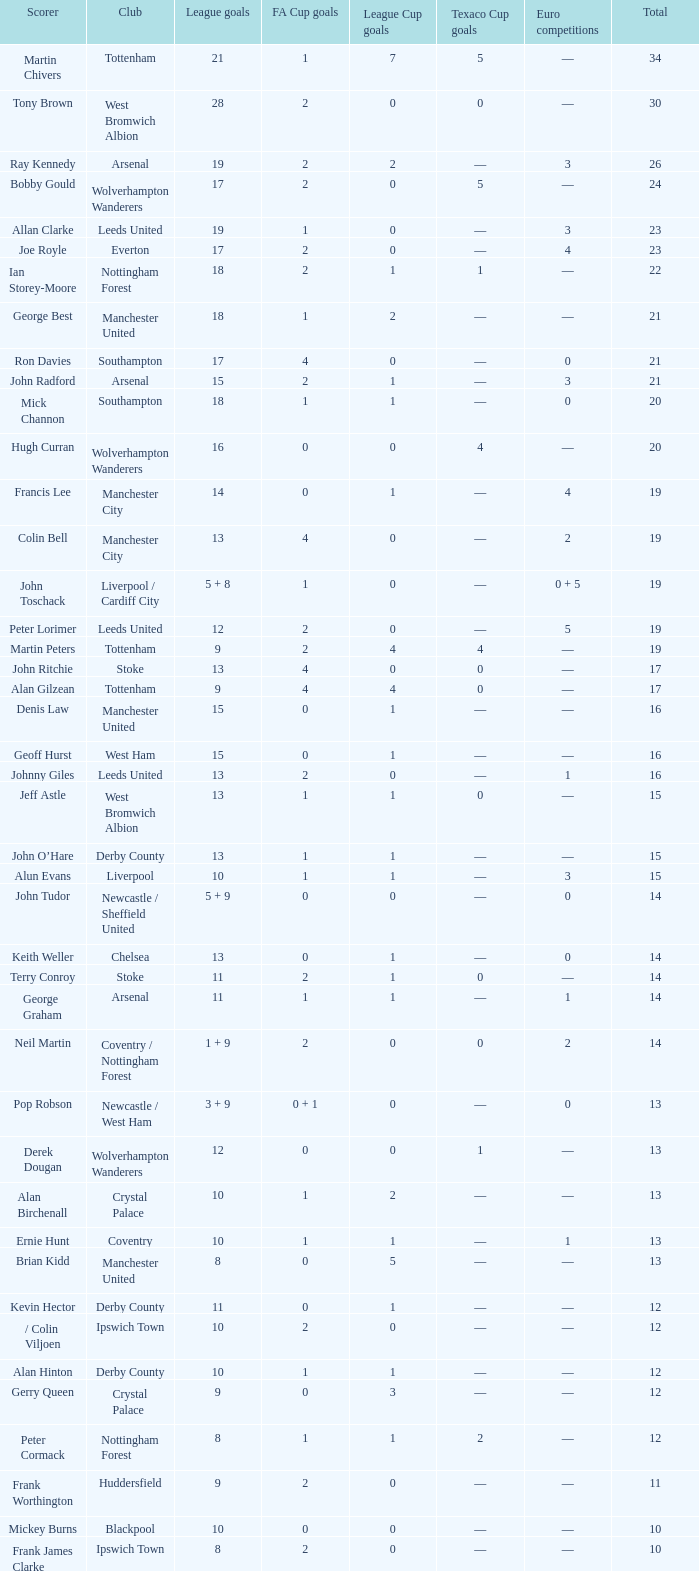If euro competitions has 1 and league goals has 11, what is the number of fa cup goals? 1.0. 